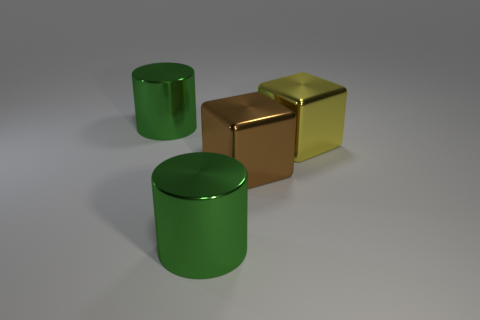How many things are either metallic cylinders or cylinders that are in front of the brown metallic object?
Offer a terse response. 2. Is the number of brown metallic balls greater than the number of green metal cylinders?
Keep it short and to the point. No. Are there any other brown cubes that have the same material as the large brown cube?
Provide a succinct answer. No. There is a large metal thing that is both to the left of the yellow thing and behind the brown block; what shape is it?
Make the answer very short. Cylinder. How many other objects are there of the same shape as the large brown metallic object?
Ensure brevity in your answer.  1. How big is the brown cube?
Ensure brevity in your answer.  Large. What number of objects are either big brown shiny blocks or large things?
Keep it short and to the point. 4. There is a yellow block that is behind the brown cube; what is its size?
Provide a short and direct response. Large. Are there any other things that have the same size as the brown metal object?
Provide a succinct answer. Yes. What is the color of the metal object that is both behind the large brown metallic thing and to the left of the yellow object?
Ensure brevity in your answer.  Green. 